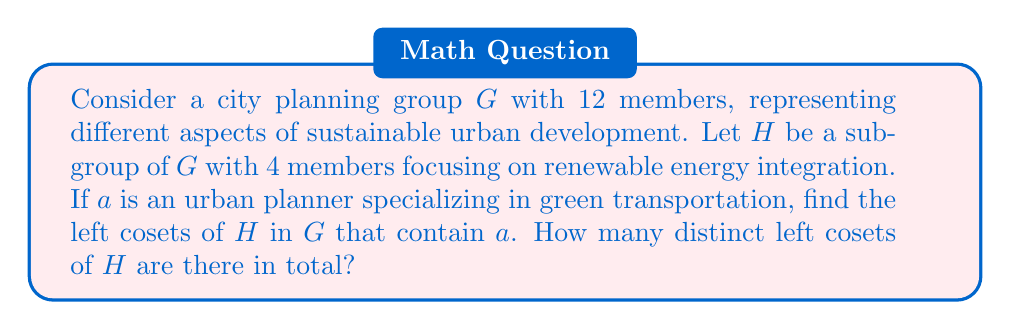Can you answer this question? Let's approach this step-by-step:

1) First, recall that for a group $G$ and a subgroup $H$, the left cosets of $H$ in $G$ are sets of the form $gH = \{gh : h \in H\}$ for $g \in G$.

2) The number of distinct left cosets is given by the index of $H$ in $G$, denoted $[G:H]$, which is equal to $\frac{|G|}{|H|}$ where $|G|$ and $|H|$ are the orders of $G$ and $H$ respectively.

3) In this case, $|G| = 12$ and $|H| = 4$. So:

   $$[G:H] = \frac{|G|}{|H|} = \frac{12}{4} = 3$$

4) This means there are 3 distinct left cosets of $H$ in $G$.

5) To find the specific coset containing $a$, we need to compute $aH$. However, without more information about the group operation, we can't determine the exact elements of this coset.

6) What we do know is that $a$ will be in exactly one of these three cosets, and this coset will contain all elements of the form $ah$ where $h \in H$.

7) The other two cosets will not contain $a$.

This problem models sustainable urban planning by representing different aspects (like renewable energy and green transportation) as elements of a group, with subgroups focusing on specific areas. The cosets represent how these focus areas interact with other aspects of urban planning.
Answer: There are 3 distinct left cosets of $H$ in $G$, and $a$ is contained in exactly one of these cosets, namely $aH$. 